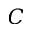<formula> <loc_0><loc_0><loc_500><loc_500>C</formula> 